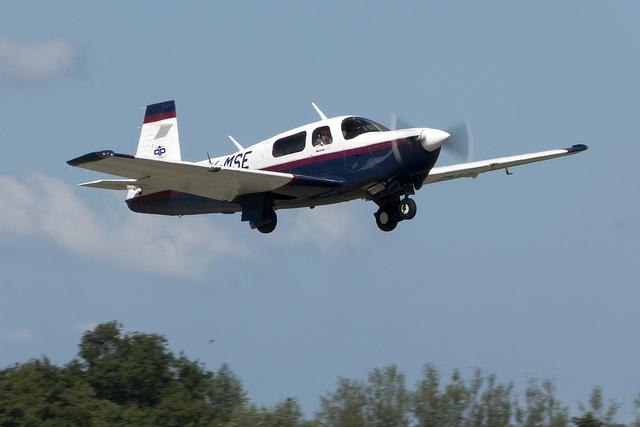Can 100 people fit in this plane?
Concise answer only. No. Is the sky cloudy?
Write a very short answer. No. Does this airplane have propellers?
Be succinct. Yes. Do you think this plane is going to England?
Write a very short answer. No. What is the position of the landing gear?
Short answer required. Down. 